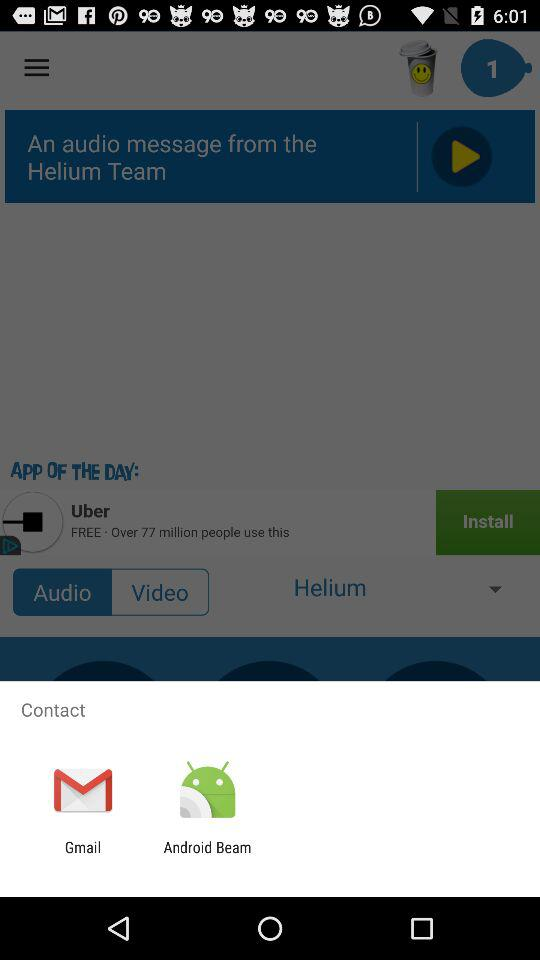How many unread messages are there? There is 1 unread message. 